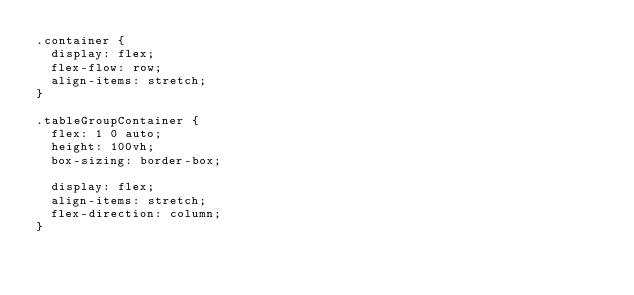<code> <loc_0><loc_0><loc_500><loc_500><_CSS_>.container {
  display: flex;
  flex-flow: row;
  align-items: stretch;
}

.tableGroupContainer {
  flex: 1 0 auto;
  height: 100vh;
  box-sizing: border-box;

  display: flex;
  align-items: stretch;
  flex-direction: column;
}
</code> 